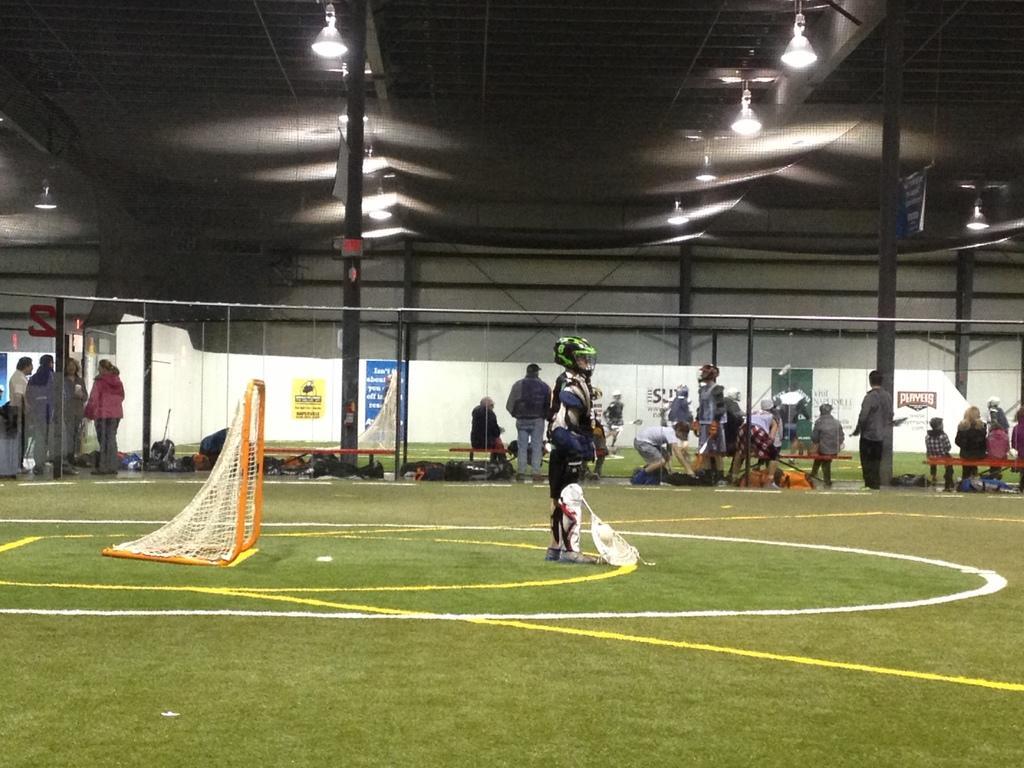How would you summarize this image in a sentence or two? In this image I can see an open grass ground and on it I can see number of lines, a goal post and one person is standing. I can see this person is wearing a helmet, a knee guard, gloves and I can also see this person is holding a stick. In the background I can see number of people where few are standing and rest all are sitting on benches. I can also see few bags, few boards and on these boards I can see something is written. On the top side of the image I can see number of lights, few poles and few more boards. 